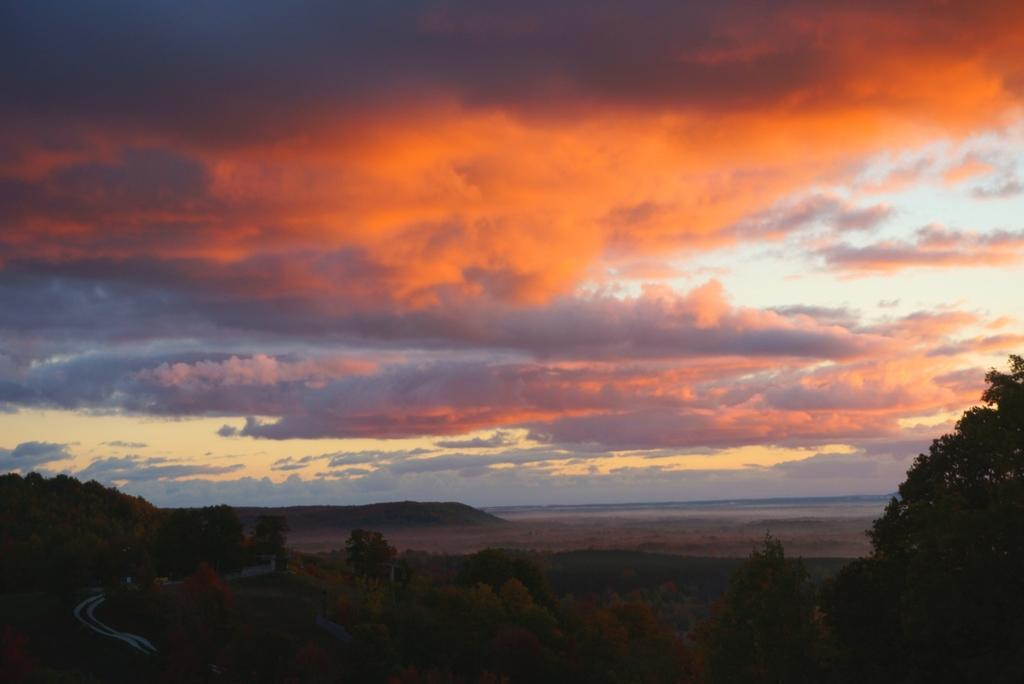What type of vegetation can be seen in the image? There are trees in the image. What natural feature is visible in the background of the image? There are mountains in the background of the image. What is the color of the sky in the image? The sky has an orange color. Can you see any rabbits participating in a protest in the image? There are no rabbits or protests present in the image. 